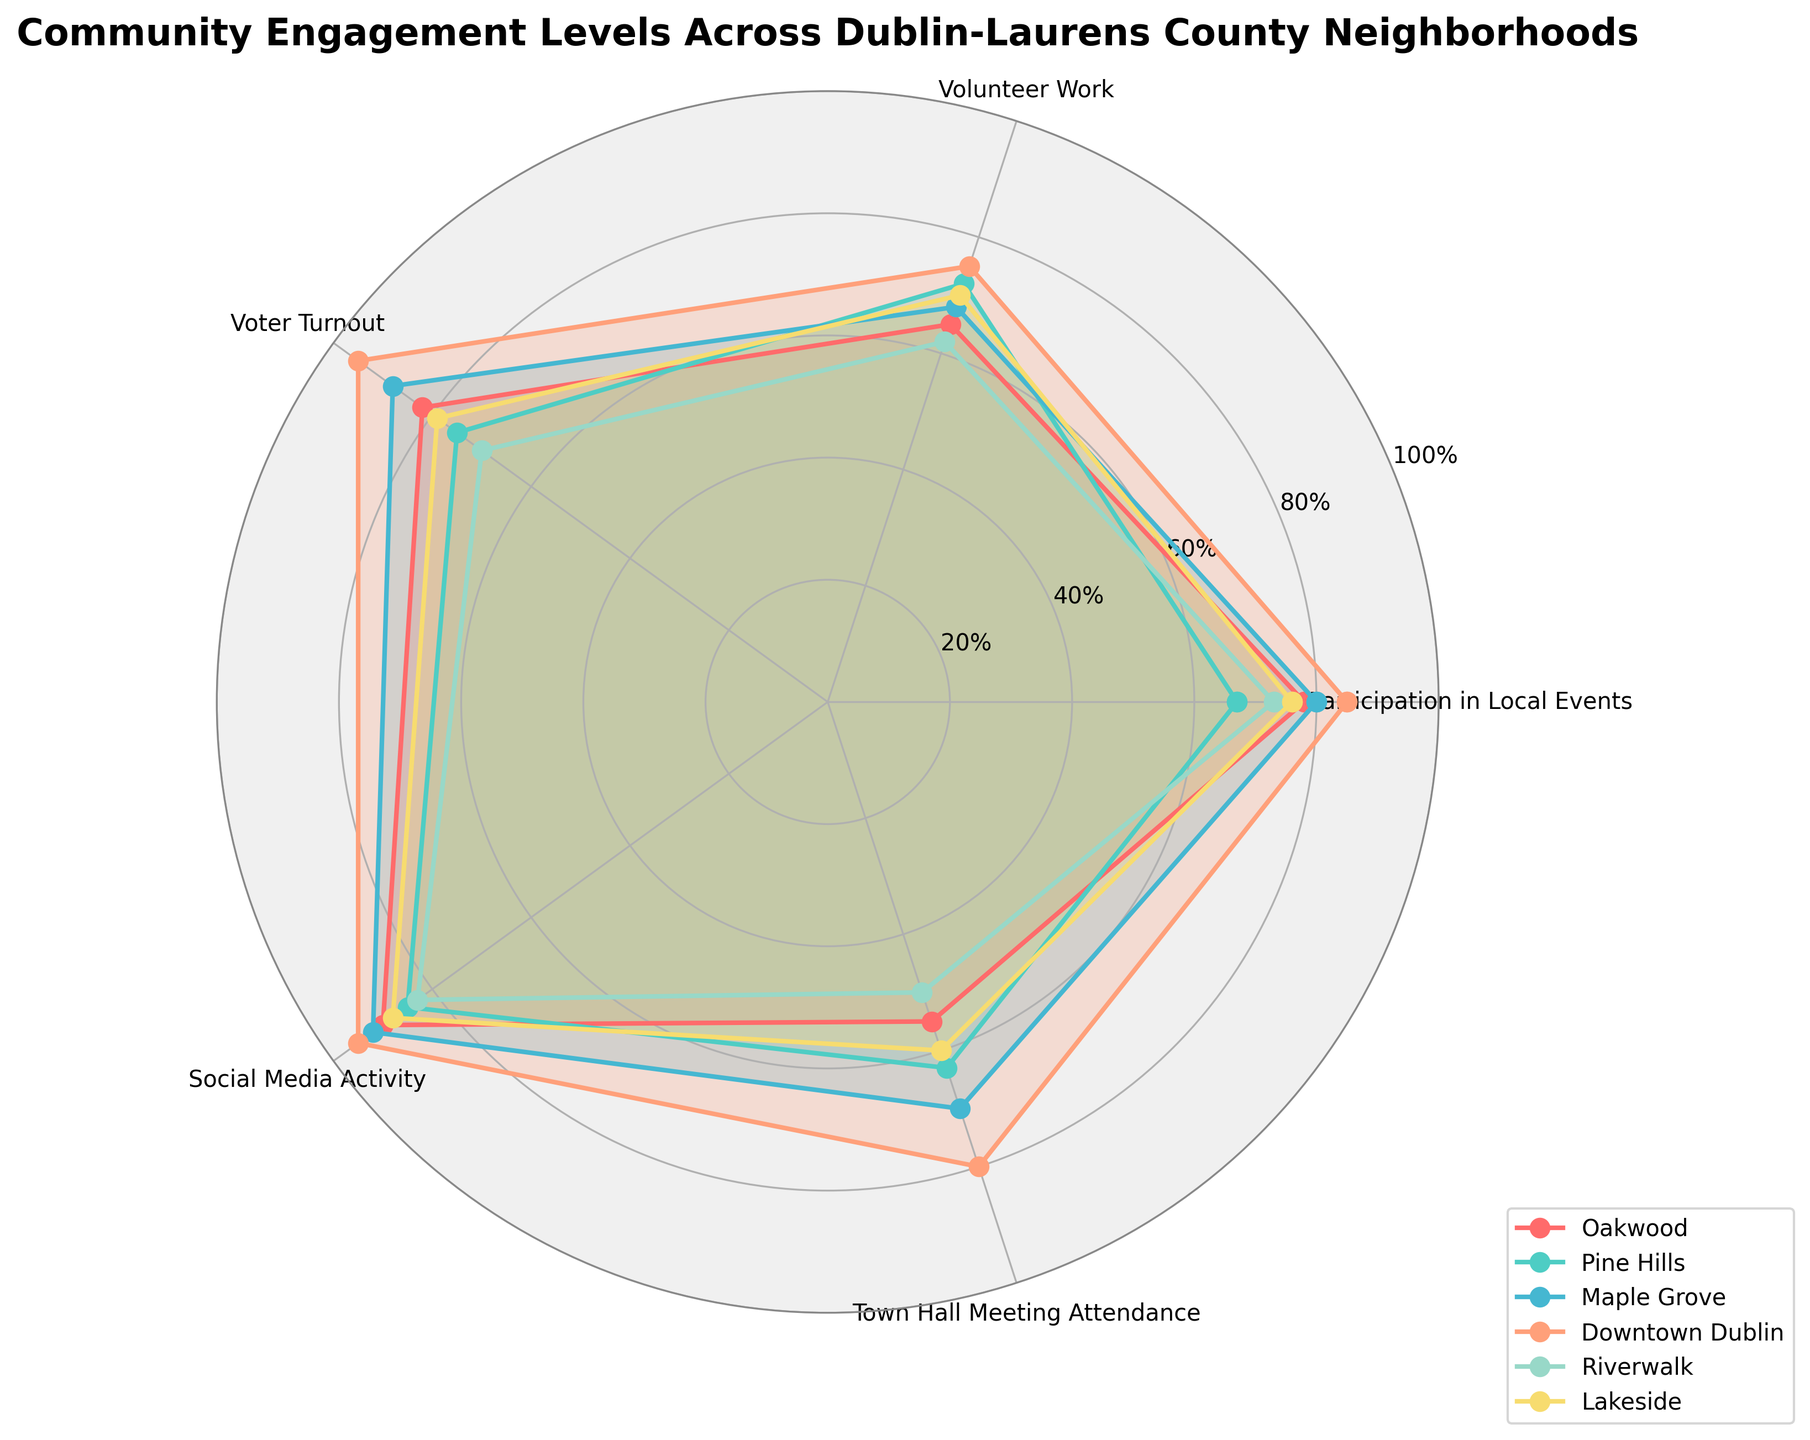How many neighborhoods are compared in this figure? The figure includes six neighborhoods: Oakwood, Pine Hills, Maple Grove, Downtown Dublin, Riverwalk, and Lakeside. This is evident from the legend in the radar chart.
Answer: Six Which category shows the highest participation for Downtown Dublin? From the radar chart, Downtown Dublin has its highest value at 'Social Media Activity' with a value of 95%.
Answer: Social Media Activity What is the average voter turnout across all neighborhoods? The voter turnout percentages for each neighborhood are: Oakwood (82), Pine Hills (75), Maple Grove (88), Downtown Dublin (95), Riverwalk (70), and Lakeside (79). Sum these values to get 489, then divide by the number of neighborhoods (6): 489 / 6 = 81.5%.
Answer: 81.5% Which neighborhood has the lowest town hall meeting attendance? The radar chart shows that Riverwalk has the lowest town hall meeting attendance with a value of 50%.
Answer: Riverwalk Is Social Media Activity generally higher than Volunteer Work in these neighborhoods? To determine this, compare the values for Social Media Activity and Volunteer Work for each neighborhood: Oakwood (90 vs. 65), Pine Hills (85 vs. 72), Maple Grove (92 vs. 68), Downtown Dublin (95 vs. 75), Riverwalk (83 vs. 62), Lakeside (88 vs. 70). In all cases, Social Media Activity values are higher.
Answer: Yes Which has higher average participation, local events or town hall meetings? The average participation in local events: (78, 67, 80, 85, 73, 76) sums to 459 and averages to 459/6 = 76.5%. The average attendance in town hall meetings: (55, 63, 70, 80, 50, 60) sums to 378 and averages to 378/6 = 63%. Thus, local events have higher average participation.
Answer: Local events Which two neighborhoods have the most similar profiles across all categories? Compare the radar shapes visually. Lakeside and Pine Hills have very similar shapes and values across all categories: Participation in Local Events (76 vs. 67), Volunteer Work (70 vs. 72), Voter Turnout (79 vs. 75), Social Media Activity (88 vs. 85), Town Hall Meeting Attendance (60 vs. 63), indicating similar profiles.
Answer: Lakeside and Pine Hills Which category shows the smallest difference in participation between the highest and lowest values? Calculate the differences for each category: Local Events (85 - 67 = 18), Volunteer Work (75 - 62 = 13), Voter Turnout (95 - 70 = 25), Social Media Activity (95 - 83 = 12), Town Hall Meeting Attendance (80 - 50 = 30). The smallest difference is for Social Media Activity (12%).
Answer: Social Media Activity Do any neighborhoods have the same level of participation in any category? Check the radar chart for identical values across categories. None of the neighborhoods show identical values in any given category, indicating unique engagement profiles.
Answer: No 